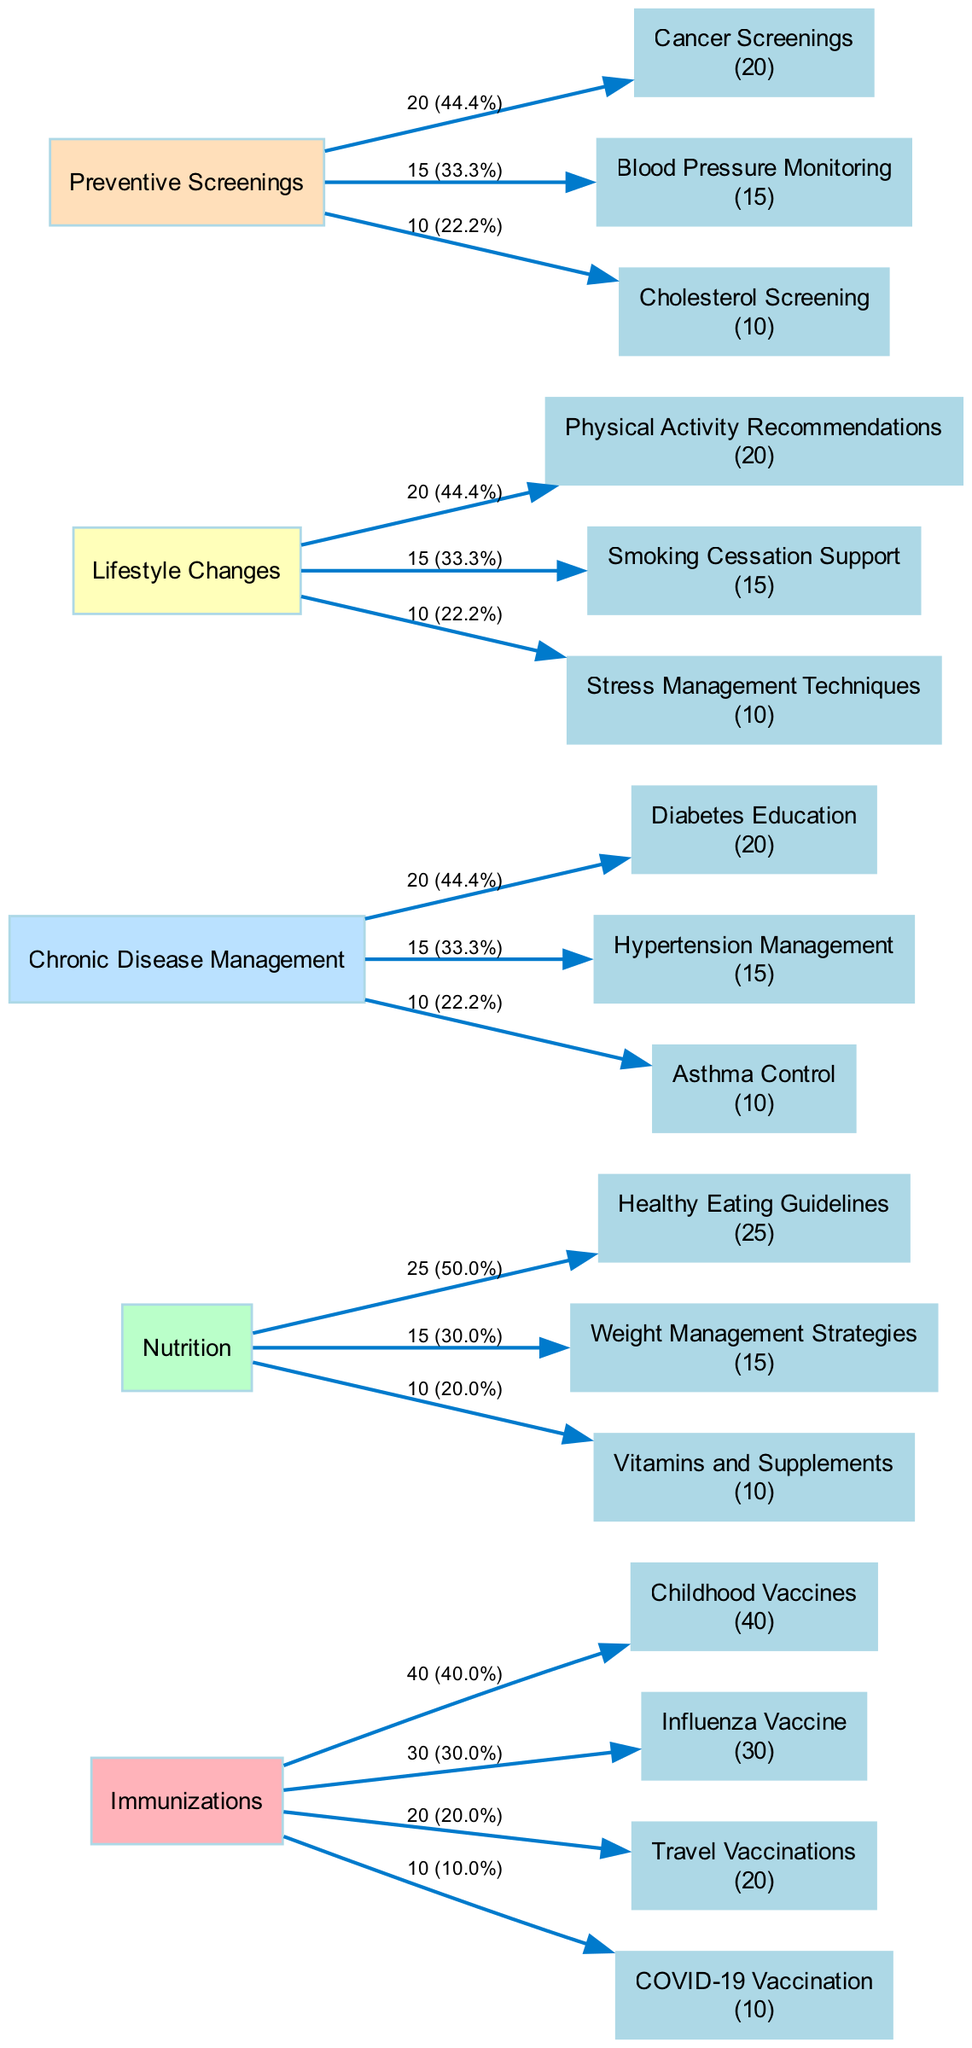What is the total number of health education topics covered? The diagram shows five main health education topics: Immunizations, Nutrition, Chronic Disease Management, Lifestyle Changes, and Preventive Screenings. To find the total, count these topics.
Answer: 5 Which subtopic under Immunizations has the highest value? In the Immunizations category, the subtopics and their corresponding values are: Childhood Vaccines (40), Influenza Vaccine (30), Travel Vaccinations (20), and COVID-19 Vaccination (10). Comparing these values reveals that Childhood Vaccines has the highest value of 40.
Answer: Childhood Vaccines What percentage of the Nutrition topics is covered by Healthy Eating Guidelines? The total value for the Nutrition topics is 25 (Healthy Eating Guidelines) + 15 (Weight Management Strategies) + 10 (Vitamins and Supplements) = 50. To calculate the percentage, take the value of Healthy Eating Guidelines (25) divided by the total (50) and multiply by 100, resulting in 50%.
Answer: 50% How many subtopics are associated with Lifestyle Changes? Under the Lifestyle Changes category, the subtopics listed are Physical Activity Recommendations, Smoking Cessation Support, and Stress Management Techniques. Counting these subtopics provides the answer.
Answer: 3 What is the total value of subtopics under Chronic Disease Management? The subtopics under Chronic Disease Management and their values are: Diabetes Education (20), Hypertension Management (15), and Asthma Control (10). Summing these values: 20 + 15 + 10 = 45.
Answer: 45 Which main topic has the lowest total value of subtopics? The total values for the main topics are: Immunizations (100), Nutrition (50), Chronic Disease Management (45), Lifestyle Changes (45), and Preventive Screenings (45). Both Chronic Disease Management and Lifestyle Changes have the lowest total of 45.
Answer: Chronic Disease Management, Lifestyle Changes What is the relationship between Travel Vaccinations and COVID-19 Vaccination in terms of value? Travel Vaccinations has a value of 20, while COVID-19 Vaccination has a value of 10. Comparing these values, Travel Vaccinations is greater than COVID-19 Vaccination.
Answer: Travel Vaccinations > COVID-19 Vaccination Which preventive screening has the lowest value? The preventive screenings listed and their values are: Cancer Screenings (20), Blood Pressure Monitoring (15), and Cholesterol Screening (10). The screening with the lowest value is Cholesterol Screening (10).
Answer: Cholesterol Screening How many total consultations focused on Lifestyle Changes? The total values of subtopics under Lifestyle Changes are Physical Activity Recommendations (20), Smoking Cessation Support (15), and Stress Management Techniques (10). The total is 20 + 15 + 10 = 45, indicating how many consultations focused on this topic.
Answer: 45 